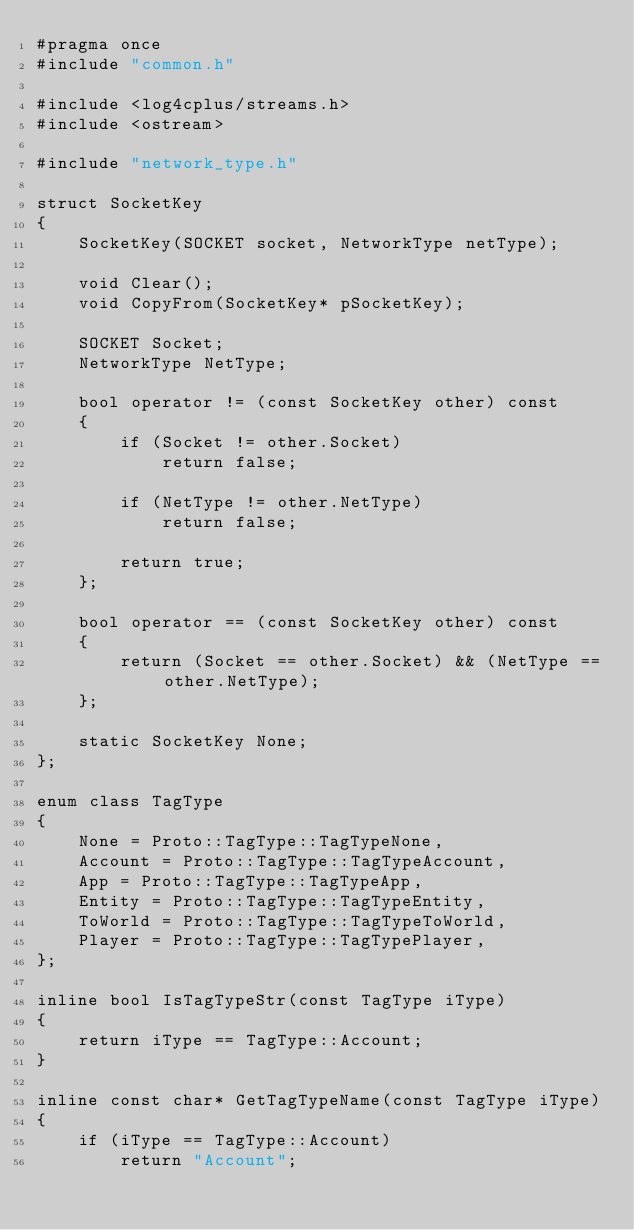Convert code to text. <code><loc_0><loc_0><loc_500><loc_500><_C_>#pragma once
#include "common.h"

#include <log4cplus/streams.h>
#include <ostream>

#include "network_type.h"

struct SocketKey
{
    SocketKey(SOCKET socket, NetworkType netType);

    void Clear();
    void CopyFrom(SocketKey* pSocketKey);

    SOCKET Socket;
    NetworkType NetType;

    bool operator != (const SocketKey other) const
    {
        if (Socket != other.Socket)
            return false;

        if (NetType != other.NetType)
            return false;

        return true;
    };

    bool operator == (const SocketKey other) const
    {
        return (Socket == other.Socket) && (NetType == other.NetType);
    };

    static SocketKey None;
};

enum class TagType
{
    None = Proto::TagType::TagTypeNone,
    Account = Proto::TagType::TagTypeAccount,
    App = Proto::TagType::TagTypeApp,
    Entity = Proto::TagType::TagTypeEntity,
    ToWorld = Proto::TagType::TagTypeToWorld,
    Player = Proto::TagType::TagTypePlayer,
};

inline bool IsTagTypeStr(const TagType iType)
{
    return iType == TagType::Account;
}

inline const char* GetTagTypeName(const TagType iType)
{
    if (iType == TagType::Account)
        return "Account";</code> 